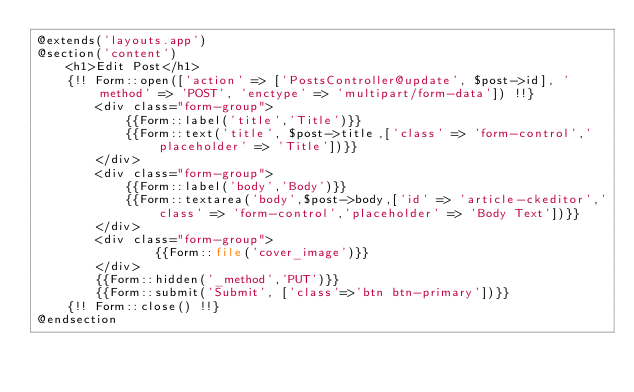Convert code to text. <code><loc_0><loc_0><loc_500><loc_500><_PHP_>@extends('layouts.app')
@section('content')
    <h1>Edit Post</h1>
    {!! Form::open(['action' => ['PostsController@update', $post->id], 'method' => 'POST', 'enctype' => 'multipart/form-data']) !!}
        <div class="form-group">
            {{Form::label('title','Title')}}
            {{Form::text('title', $post->title,['class' => 'form-control','placeholder' => 'Title'])}}
        </div>
        <div class="form-group">
            {{Form::label('body','Body')}}
            {{Form::textarea('body',$post->body,['id' => 'article-ckeditor','class' => 'form-control','placeholder' => 'Body Text'])}}
        </div>
        <div class="form-group">
                {{Form::file('cover_image')}}
        </div>
        {{Form::hidden('_method','PUT')}}
        {{Form::submit('Submit', ['class'=>'btn btn-primary'])}}
    {!! Form::close() !!}
@endsection</code> 